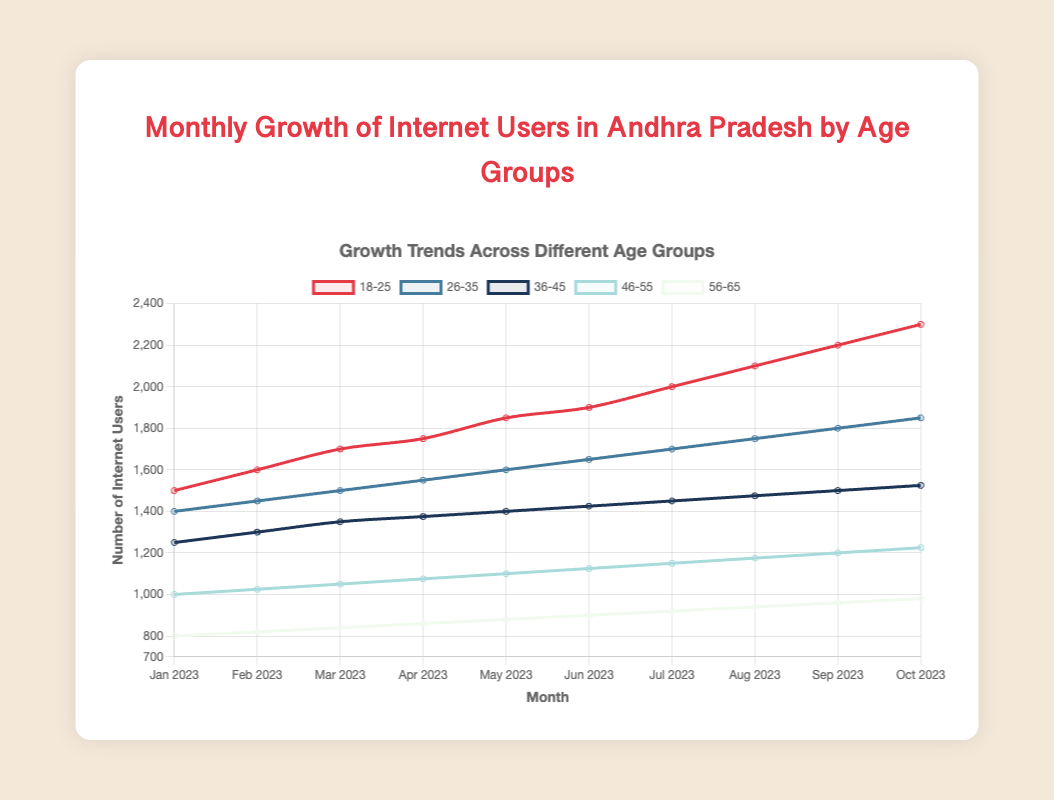How many more internet users are there in the 18-25 age group compared to the 26-35 age group in October 2023? In October 2023, the number of internet users in the 18-25 age group is 2300, and in the 26-35 age group, it is 1850. To find the difference, subtract 1850 from 2300.
Answer: 450 Which age group shows the largest increase in internet users from January 2023 to October 2023? Calculate the increase for each age group by subtracting the January 2023 value from the October 2023 value and compare the results. The increases are: 18-25: 800, 26-35: 450, 36-45: 275, 46-55: 225, 56-65: 180. The largest increase is in the 18-25 age group.
Answer: 18-25 What is the average number of internet users in the 36-45 age group over the 10 months? Add the internet users in the 36-45 age group for each month (1250 + 1300 + 1350 + 1375 + 1400 + 1425 + 1450 + 1475 + 1500 + 1525) and divide by the number of months (10).
Answer: 1405 Between which months does the 46-55 age group experience the least growth? Review the growth between each month by subtracting the users from the next month. The growth between months are: (1025-1000), (1050-1025), (1075-1050), etc. The smallest growth is 25 users, occurring between each pair of consecutive months as the growth pattern is consistent.
Answer: All pairs have consistent growth of 25 Which age group has the least number of internet users in September 2023? Check the number of internet users for all age groups in September 2023. The values are: 18-25: 2200, 26-35: 1800, 36-45: 1500, 46-55: 1200, 56-65: 960. The least number of users is in the 56-65 age group.
Answer: 56-65 Which two age groups have the closest number of internet users in April 2023? Compare the number of internet users in April 2023 for all age groups: 18-25: 1750, 26-35: 1550, 36-45: 1375, 46-55: 1075, 56-65: 860. The closest numbers are 36-45 and 26-35 with a difference of 175 users (1550 - 1375).
Answer: 36-45 and 26-35 In which month did the 26-35 age group surpass 1500 internet users? Look at the data for the 26-35 age group across months. The count surpasses 1500 in March 2023 where it reaches 1500.
Answer: March 2023 How does the growth trend of the 18-25 age group compare visually with the 56-65 age group? Notice the slopes of the lines. The 18-25 group shows a steeper incline indicating a faster growth rate compared to the 56-65 group which has a more gradual rise.
Answer: Steeper incline for 18-25 What's the total number of internet users added across all age groups from January to October 2023? Calculate the difference for each age group and sum them up: 18-25: 800, 26-35: 450, 36-45: 275, 46-55: 225, 56-65: 180. Total addition: 800 + 450 + 275 + 225 + 180.
Answer: 1930 